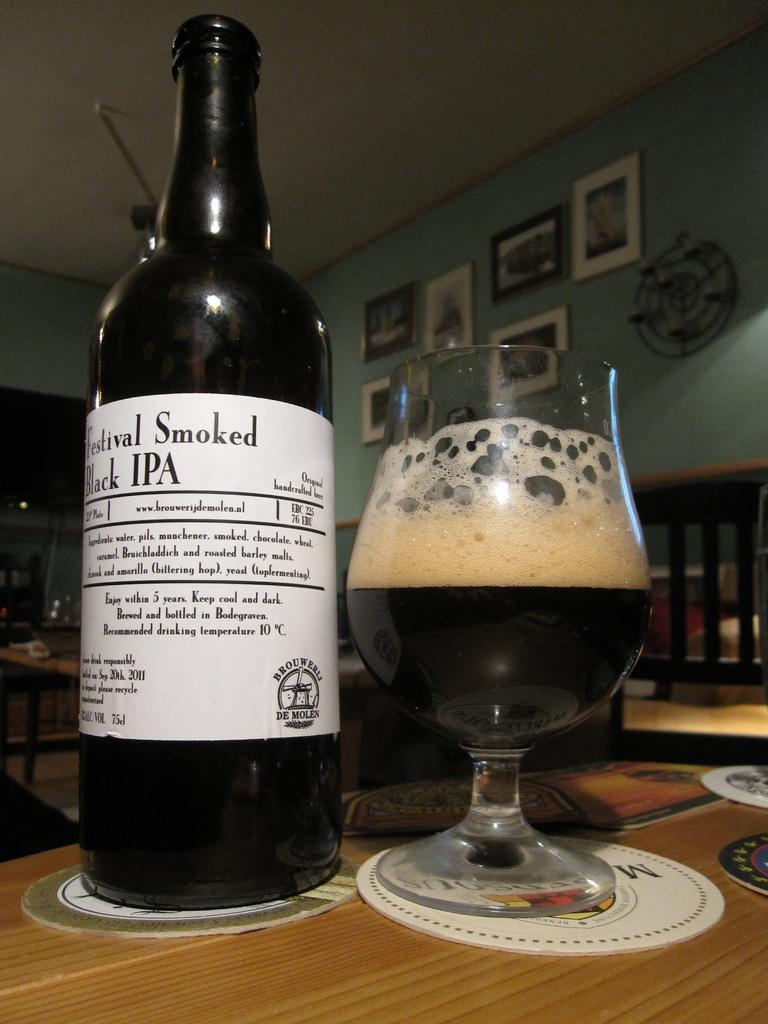<image>
Create a compact narrative representing the image presented. The drink in the bottle is a black IPA 